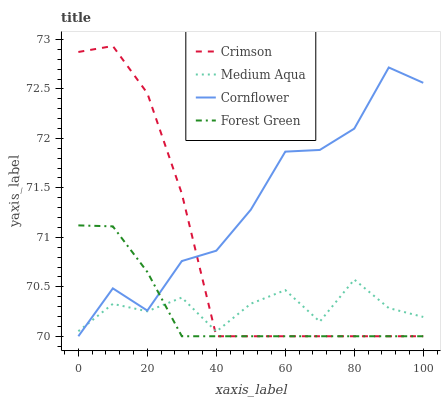Does Forest Green have the minimum area under the curve?
Answer yes or no. Yes. Does Cornflower have the maximum area under the curve?
Answer yes or no. Yes. Does Cornflower have the minimum area under the curve?
Answer yes or no. No. Does Forest Green have the maximum area under the curve?
Answer yes or no. No. Is Forest Green the smoothest?
Answer yes or no. Yes. Is Cornflower the roughest?
Answer yes or no. Yes. Is Cornflower the smoothest?
Answer yes or no. No. Is Forest Green the roughest?
Answer yes or no. No. Does Crimson have the lowest value?
Answer yes or no. Yes. Does Medium Aqua have the lowest value?
Answer yes or no. No. Does Crimson have the highest value?
Answer yes or no. Yes. Does Cornflower have the highest value?
Answer yes or no. No. Does Medium Aqua intersect Crimson?
Answer yes or no. Yes. Is Medium Aqua less than Crimson?
Answer yes or no. No. Is Medium Aqua greater than Crimson?
Answer yes or no. No. 